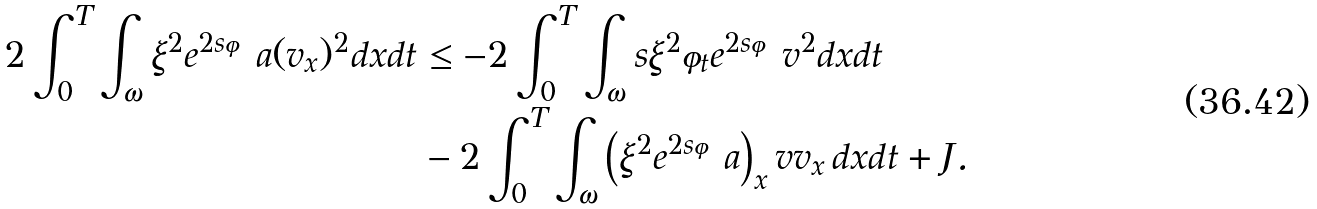Convert formula to latex. <formula><loc_0><loc_0><loc_500><loc_500>2 \int _ { 0 } ^ { T } \int _ { \omega } \xi ^ { 2 } e ^ { 2 s \varphi } a ( v _ { x } ) ^ { 2 } d x d t & \leq - 2 \int _ { 0 } ^ { T } \int _ { \omega } s \xi ^ { 2 } \varphi _ { t } e ^ { 2 s \varphi } v ^ { 2 } d x d t \\ & - 2 \int _ { 0 } ^ { T } \int _ { \omega } \left ( \xi ^ { 2 } e ^ { 2 s \varphi } a \right ) _ { x } v v _ { x } \, d x d t + J .</formula> 